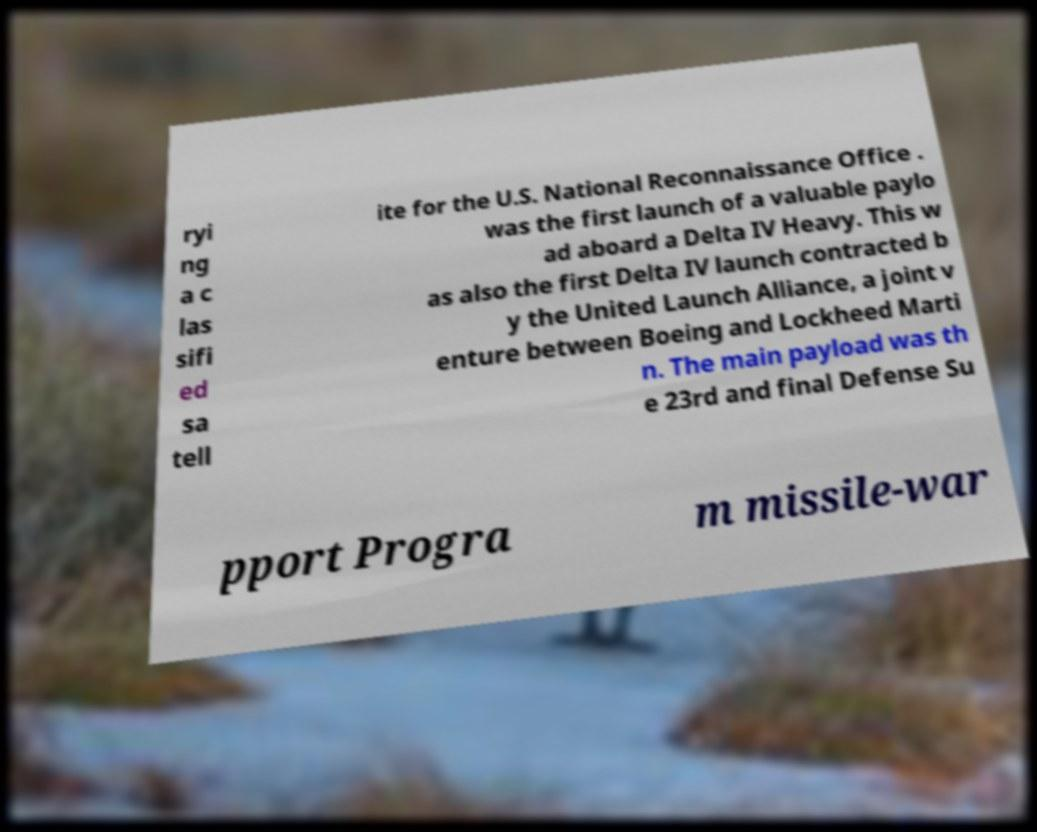What messages or text are displayed in this image? I need them in a readable, typed format. ryi ng a c las sifi ed sa tell ite for the U.S. National Reconnaissance Office . was the first launch of a valuable paylo ad aboard a Delta IV Heavy. This w as also the first Delta IV launch contracted b y the United Launch Alliance, a joint v enture between Boeing and Lockheed Marti n. The main payload was th e 23rd and final Defense Su pport Progra m missile-war 